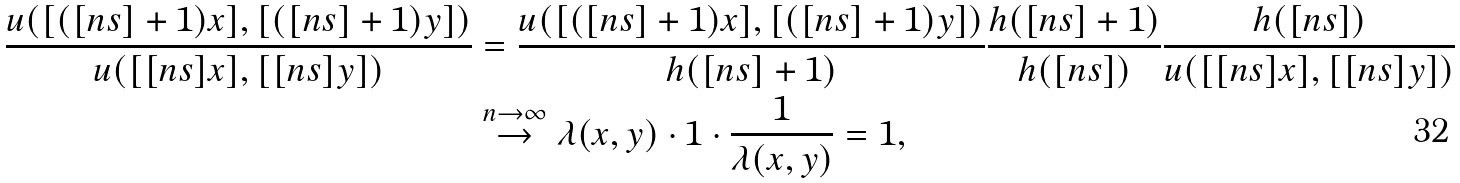Convert formula to latex. <formula><loc_0><loc_0><loc_500><loc_500>\frac { u ( [ ( [ n s ] + 1 ) x ] , [ ( [ n s ] + 1 ) y ] ) } { u ( [ [ n s ] x ] , [ [ n s ] y ] ) } & = \frac { u ( [ ( [ n s ] + 1 ) x ] , [ ( [ n s ] + 1 ) y ] ) } { h ( [ n s ] + 1 ) } \frac { h ( [ n s ] + 1 ) } { h ( [ n s ] ) } \frac { h ( [ n s ] ) } { u ( [ [ n s ] x ] , [ [ n s ] y ] ) } \\ & \stackrel { n \rightarrow \infty } { \rightarrow } \lambda ( x , y ) \cdot 1 \cdot \frac { 1 } { \lambda ( x , y ) } = 1 ,</formula> 